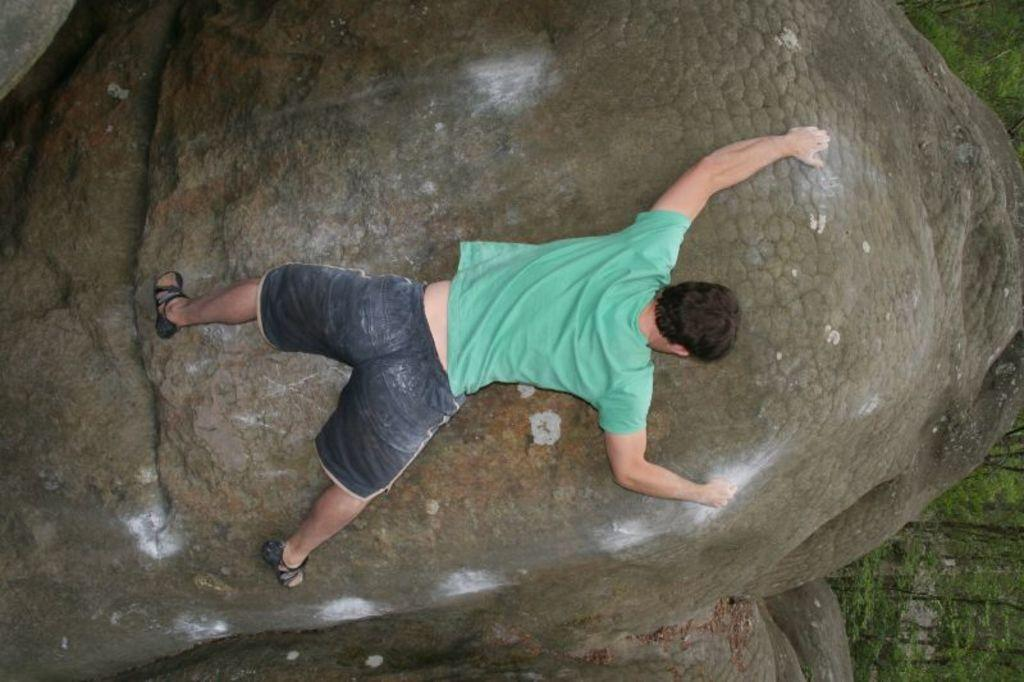What type of vegetation is on the right side of the image? There are many trees on the right side of the image. What activity is the person in the image engaged in? A person is climbing a rock in the image. What type of hair can be seen on the lizards in the image? There are no lizards present in the image, so there is no hair to be seen. 